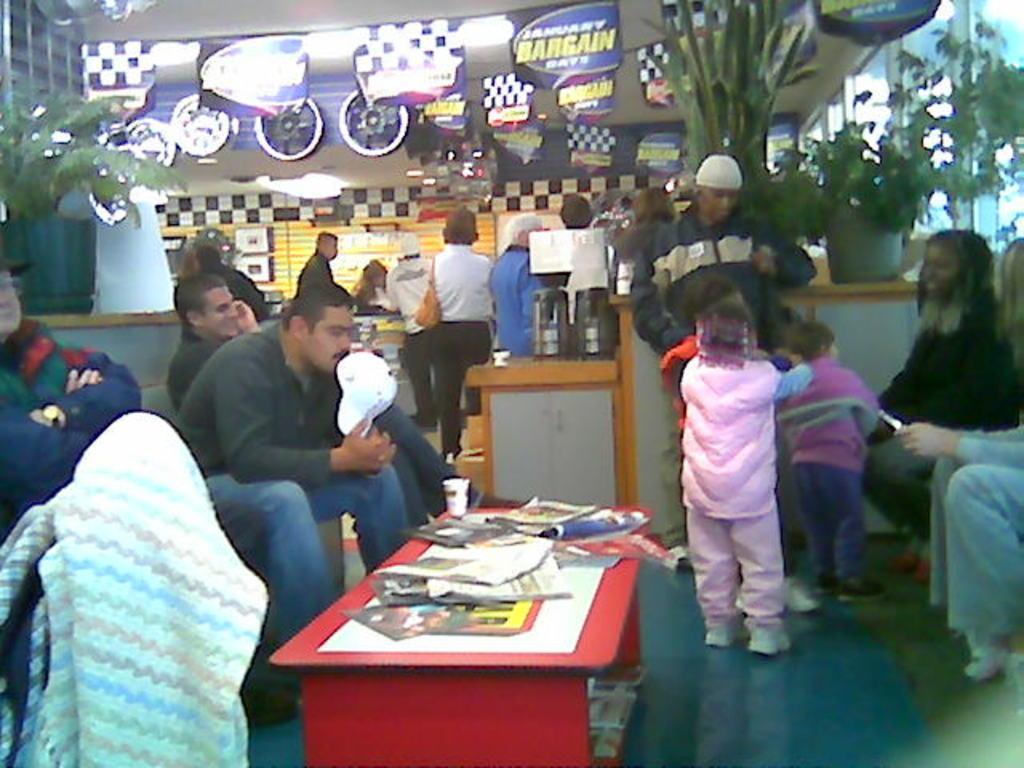In one or two sentences, can you explain what this image depicts? In a picture we can see a set of people sitting on a chairs and some are standing in the background we can find a designer walls, paintings, trees, and some plants and also we can see a red colour table with some papers on it. 